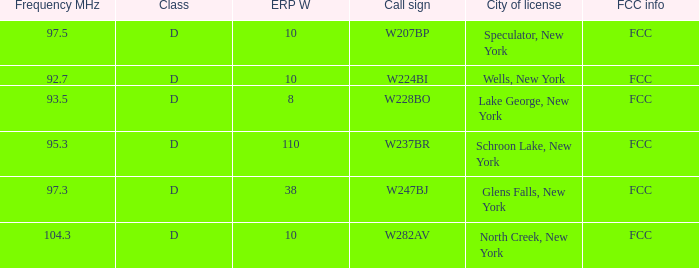Name the ERP W for frequency of 92.7 10.0. 